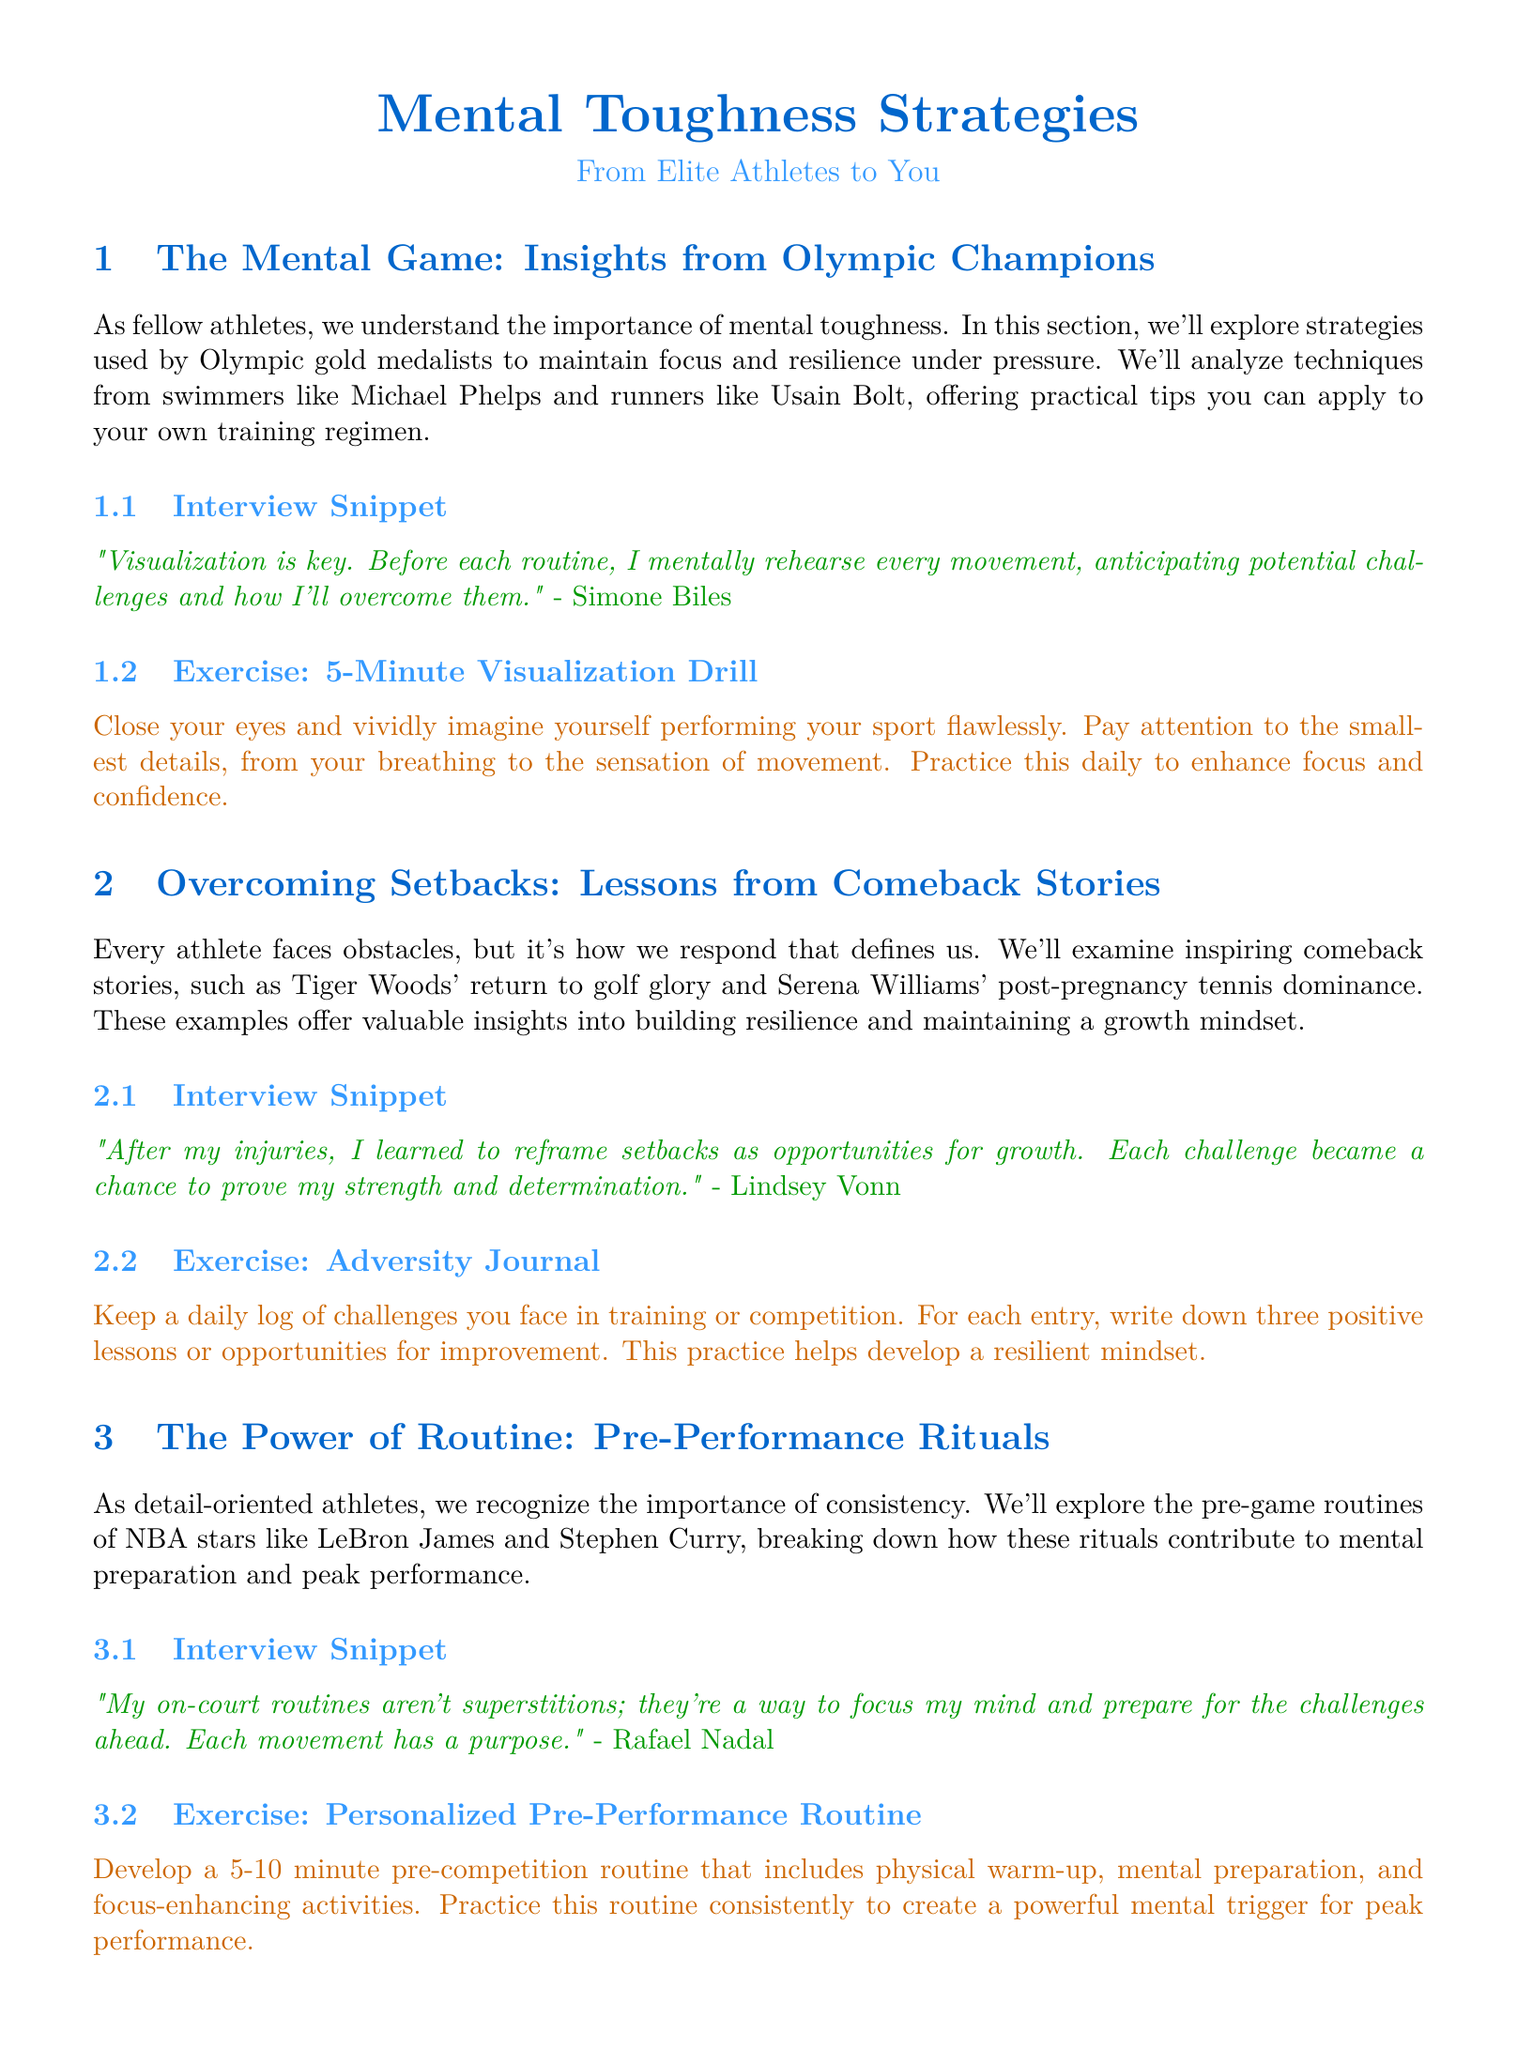What is the name of the exercise from Simone Biles' section? The exercise listed in Simone Biles' section is specifically outlined as a technique to enhance focus and confidence before routines.
Answer: 5-Minute Visualization Drill Who is quoted in the "Overcoming Setbacks" section? The document includes a quote from an athlete discussing the reframing of setbacks as growth opportunities.
Answer: Lindsey Vonn What key concept does Kevin Love associate with mindfulness? Kevin Love emphasizes the impact of a specific practice that enhances presence and stress management.
Answer: Mindfulness meditation How long should the Personalized Pre-Performance Routine last? The document specifies the duration of this routine designed to prepare athletes mentally and physically before competing.
Answer: 5-10 minutes What does Allyson Felix do to keep motivated? Allyson Felix discusses a specific strategy involving goal breakdown to maintain motivation and resilience.
Answer: Smaller, manageable targets Which athletes are featured in the "The Power of Routine" section? This section highlights two NBA stars known for their pre-game rituals that enhance focus and performance.
Answer: LeBron James and Stephen Curry What technique does the Adversity Journal help develop? This practice emphasizes the importance of reflecting on challenges and drawing positive lessons from them to build specific mental attributes.
Answer: Resilient mindset What is the main theme of the newsletter? The document revolves around strategies that elite athletes use to develop various attributes contributing to their performance in sports.
Answer: Mental Toughness Strategies 